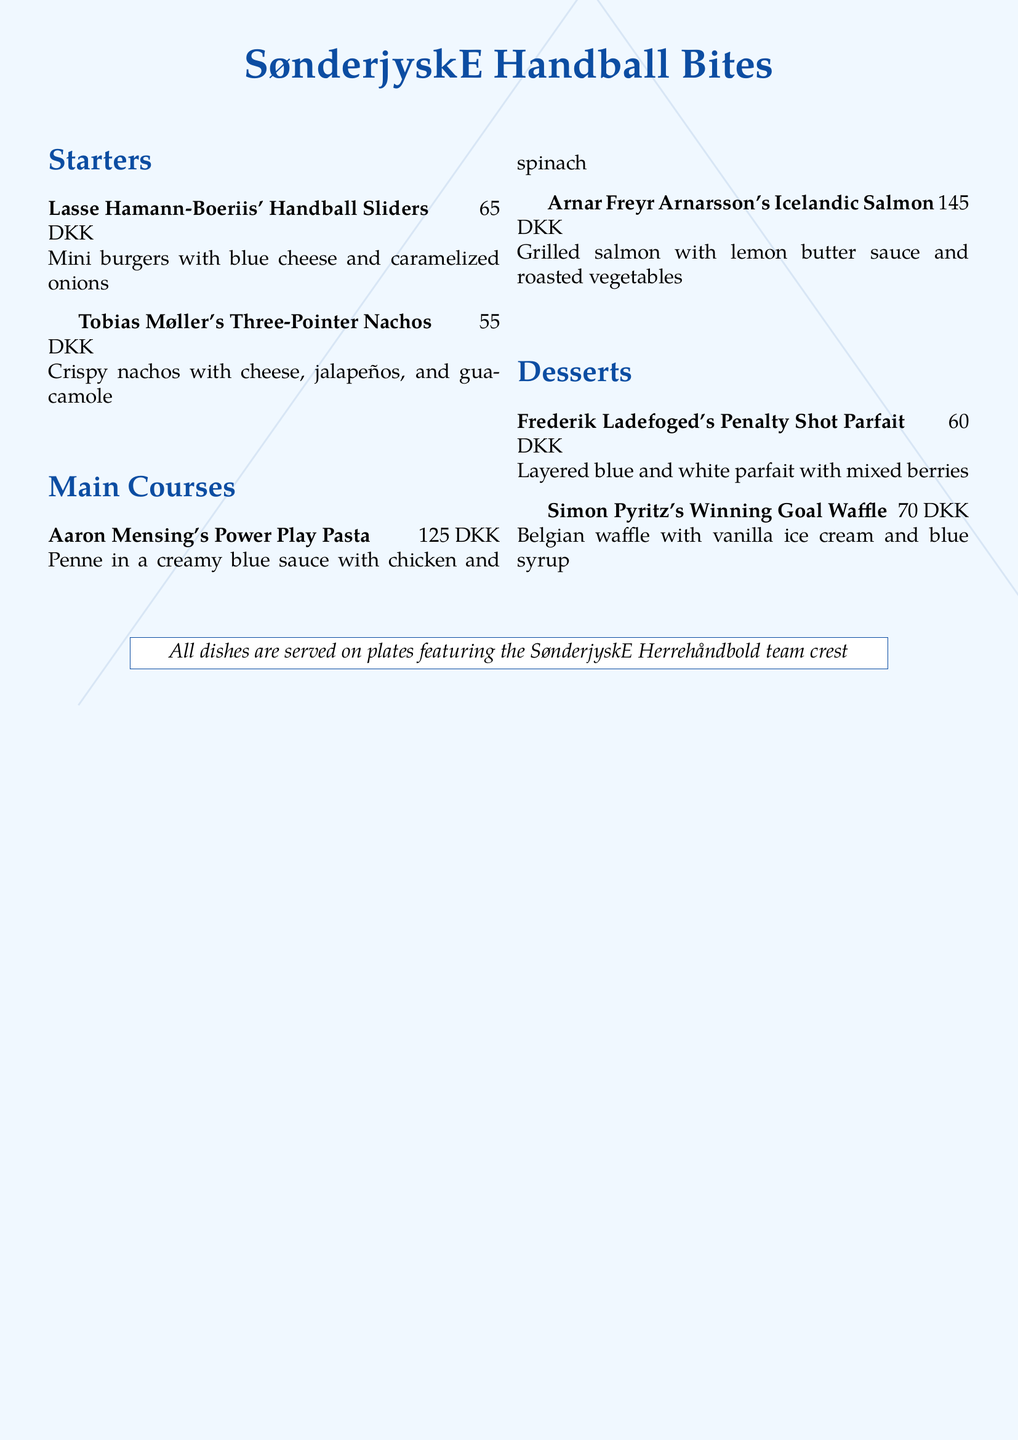What is the name of the dessert featuring mixed berries? The dessert is called "Frederik Ladefoged's Penalty Shot Parfait," which is layered blue and white parfait with mixed berries.
Answer: Frederik Ladefoged's Penalty Shot Parfait How much do the Three-Pointer Nachos cost? The price for "Tobias Møller's Three-Pointer Nachos" is clearly stated next to the dish name, which is 55 DKK.
Answer: 55 DKK Which dish is named after a player from Iceland? The dish "Arnar Freyr Arnarsson's Icelandic Salmon" includes the player's name and indicates that it is associated with Iceland.
Answer: Arnar Freyr Arnarsson's Icelandic Salmon What color scheme is used in the menu design? The menu incorporates the colors of the SønderjyskE team, specifically blue and white, as indicated in the dish descriptions and headings.
Answer: Blue and white How many starters are listed on the menu? The "Starters" section lists two dishes: "Lasse Hamann-Boeriis' Handball Sliders" and "Tobias Møller's Three-Pointer Nachos."
Answer: 2 